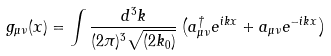<formula> <loc_0><loc_0><loc_500><loc_500>g _ { \mu \nu } ( x ) = \int \frac { d ^ { 3 } k } { ( 2 \pi ) ^ { 3 } \sqrt { ( 2 k _ { 0 } ) } } \left ( a ^ { \dag } _ { \mu \nu } e ^ { i k x } + a _ { \mu \nu } e ^ { - i k x } \right )</formula> 